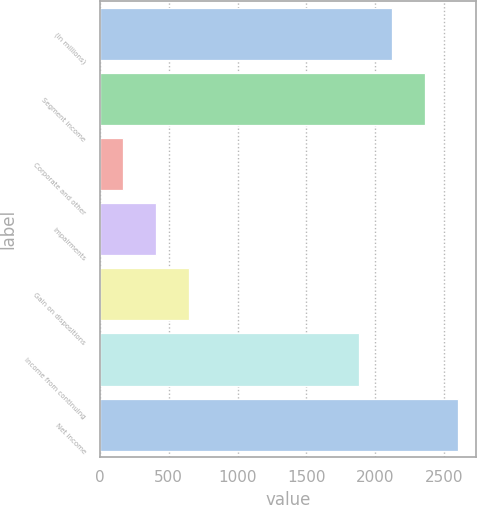<chart> <loc_0><loc_0><loc_500><loc_500><bar_chart><fcel>(In millions)<fcel>Segment income<fcel>Corporate and other<fcel>Impairments<fcel>Gain on dispositions<fcel>Income from continuing<fcel>Net income<nl><fcel>2121.8<fcel>2361.6<fcel>170<fcel>409.8<fcel>649.6<fcel>1882<fcel>2601.4<nl></chart> 